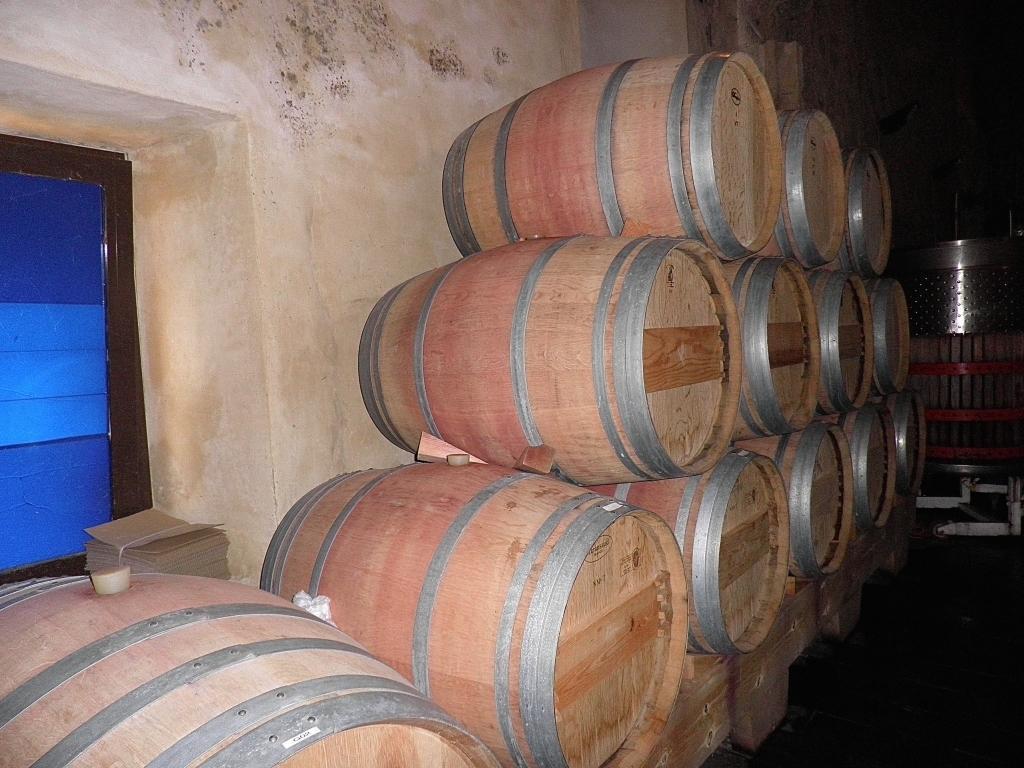Describe this image in one or two sentences. In this image, we can see some drums beside the wall. There is a window on the left side of the image. 